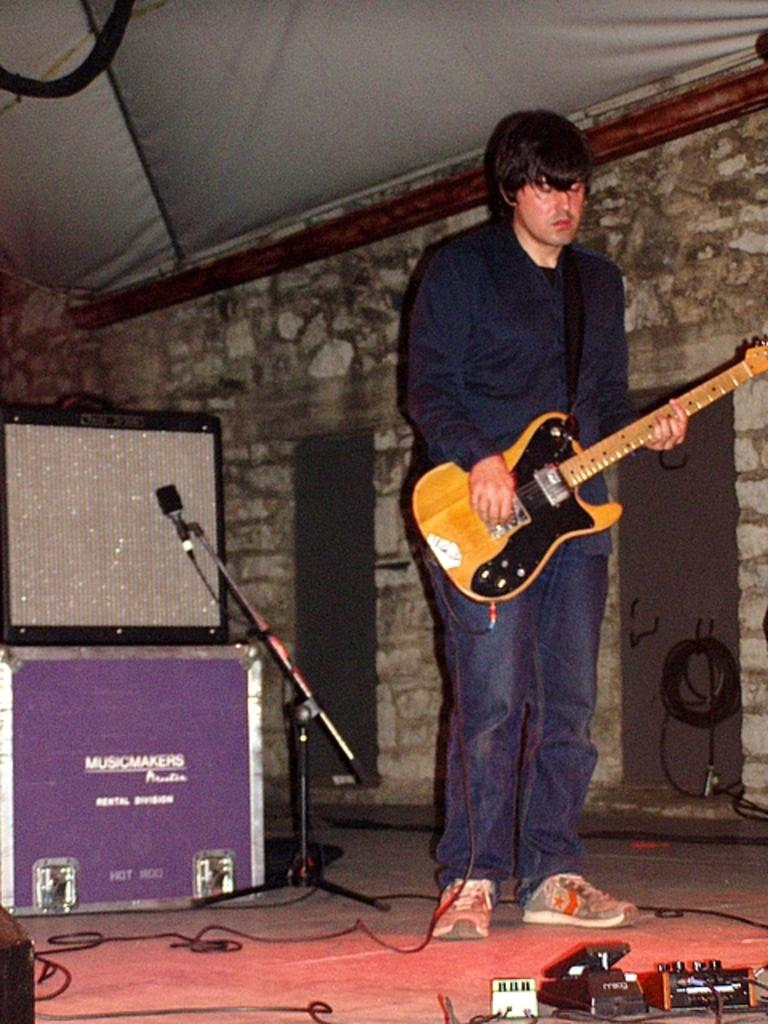Who is the main subject in the image? There is a man in the image. What is the man doing in the image? The man is playing a guitar. What object is beside the man? There is a microphone beside the man. What other equipment can be seen in the image? There are speakers in the image. How many trains can be seen in the image? There are no trains present in the image. What type of crack is visible on the guitar in the image? There is no crack visible on the guitar in the image. 